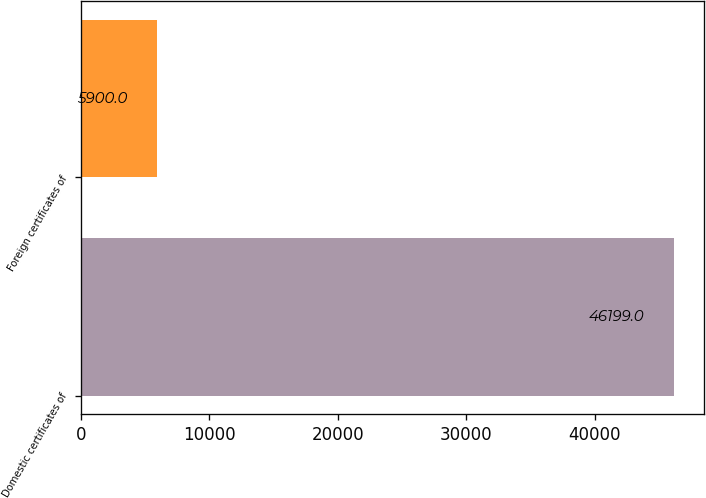Convert chart. <chart><loc_0><loc_0><loc_500><loc_500><bar_chart><fcel>Domestic certificates of<fcel>Foreign certificates of<nl><fcel>46199<fcel>5900<nl></chart> 